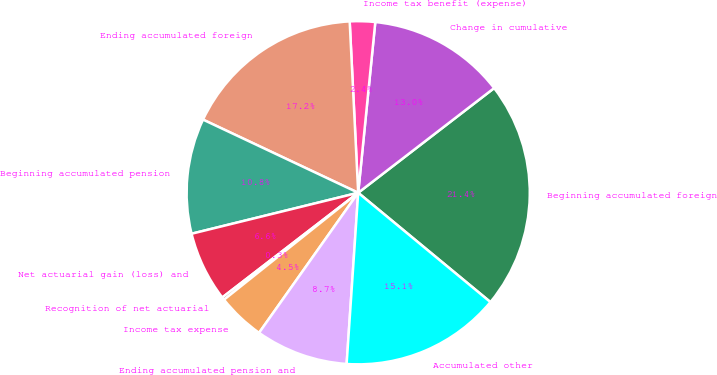Convert chart. <chart><loc_0><loc_0><loc_500><loc_500><pie_chart><fcel>Beginning accumulated foreign<fcel>Change in cumulative<fcel>Income tax benefit (expense)<fcel>Ending accumulated foreign<fcel>Beginning accumulated pension<fcel>Net actuarial gain (loss) and<fcel>Recognition of net actuarial<fcel>Income tax expense<fcel>Ending accumulated pension and<fcel>Accumulated other<nl><fcel>21.44%<fcel>12.97%<fcel>2.38%<fcel>17.2%<fcel>10.85%<fcel>6.61%<fcel>0.26%<fcel>4.49%<fcel>8.73%<fcel>15.08%<nl></chart> 